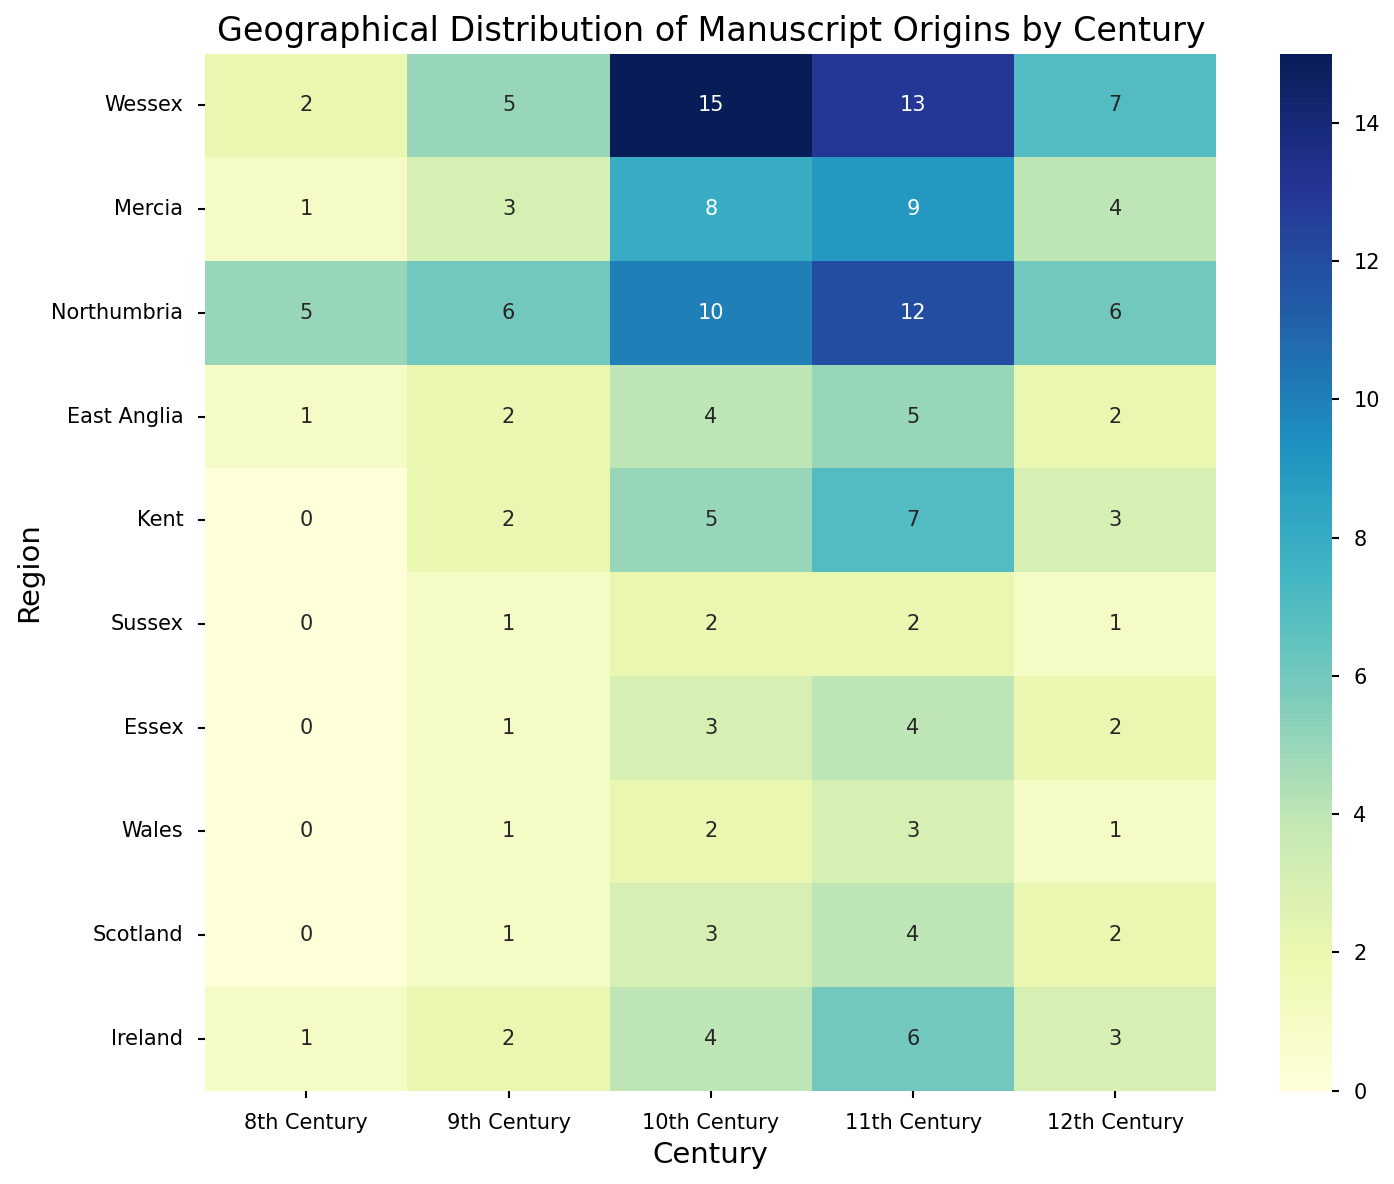What's the region with the highest number of manuscripts in the 10th century? To find the region with the highest number of manuscripts in the 10th century, look at the column labeled "10th Century." The highest value in this column is 15, which corresponds to the region "Wessex."
Answer: Wessex Which centuries have more manuscripts in Northumbria than in Mercia? Compare the values for Northumbria and Mercia across each century. In the 8th century, Northumbria has 5 while Mercia has 1; in the 9th century, Northumbria has 6 while Mercia has 3; in the 10th century, Northumbria has 10 while Mercia has 8; in the 11th century, Northumbria has 12 while Mercia has 9; in the 12th century, Northumbria has 6 while Mercia has 4. Therefore, Northumbria has more manuscripts than Mercia in all centuries listed.
Answer: 8th, 9th, 10th, 11th, 12th centuries In which century does East Anglia have the same amount of manuscripts as Scotland? Compare the values for East Anglia and Scotland across each century. In the 8th century, East Anglia has 1, and Scotland has 0; in the 9th century, East Anglia has 2, and Scotland has 1; in the 10th century, East Anglia has 4, and Scotland has 3; in the 11th century, East Anglia has 5, and Scotland has 4; in the 12th century, East Anglia has 2, and Scotland has 2. Therefore, they have the same amount in the 12th century.
Answer: 12th century What's the total number of manuscripts in Wessex across all centuries? Sum the values for Wessex across all centuries: 2 + 5 + 15 + 13 + 7 = 42.
Answer: 42 Which region has the least variation in the number of manuscripts across centuries? To determine the region with the least variation, observe the consistency of the values across centuries. Assess the regions and find the one with the most similar numbers across the centuries. For example, Wales fluctuates between 0 and 3 over the centuries, suggesting low variation compared to regions like Wessex or Northumbria.
Answer: Wales How does the geographical manuscript distribution in the 9th century compare to the 11th century? Compare the values of each region in these two columns. In the 9th century, the values are: Wessex 5, Mercia 3, Northumbria 6, East Anglia 2, Kent 2, Sussex 1, Essex 1, Wales 1, Scotland 1, Ireland 2. In the 11th century, the values are: Wessex 13, Mercia 9, Northumbria 12, East Anglia 5, Kent 7, Sussex 2, Essex 4, Wales 3, Scotland 4, Ireland 6. In general, the 11th century shows a higher number of manuscripts than the 9th century.
Answer: Higher in the 11th century 